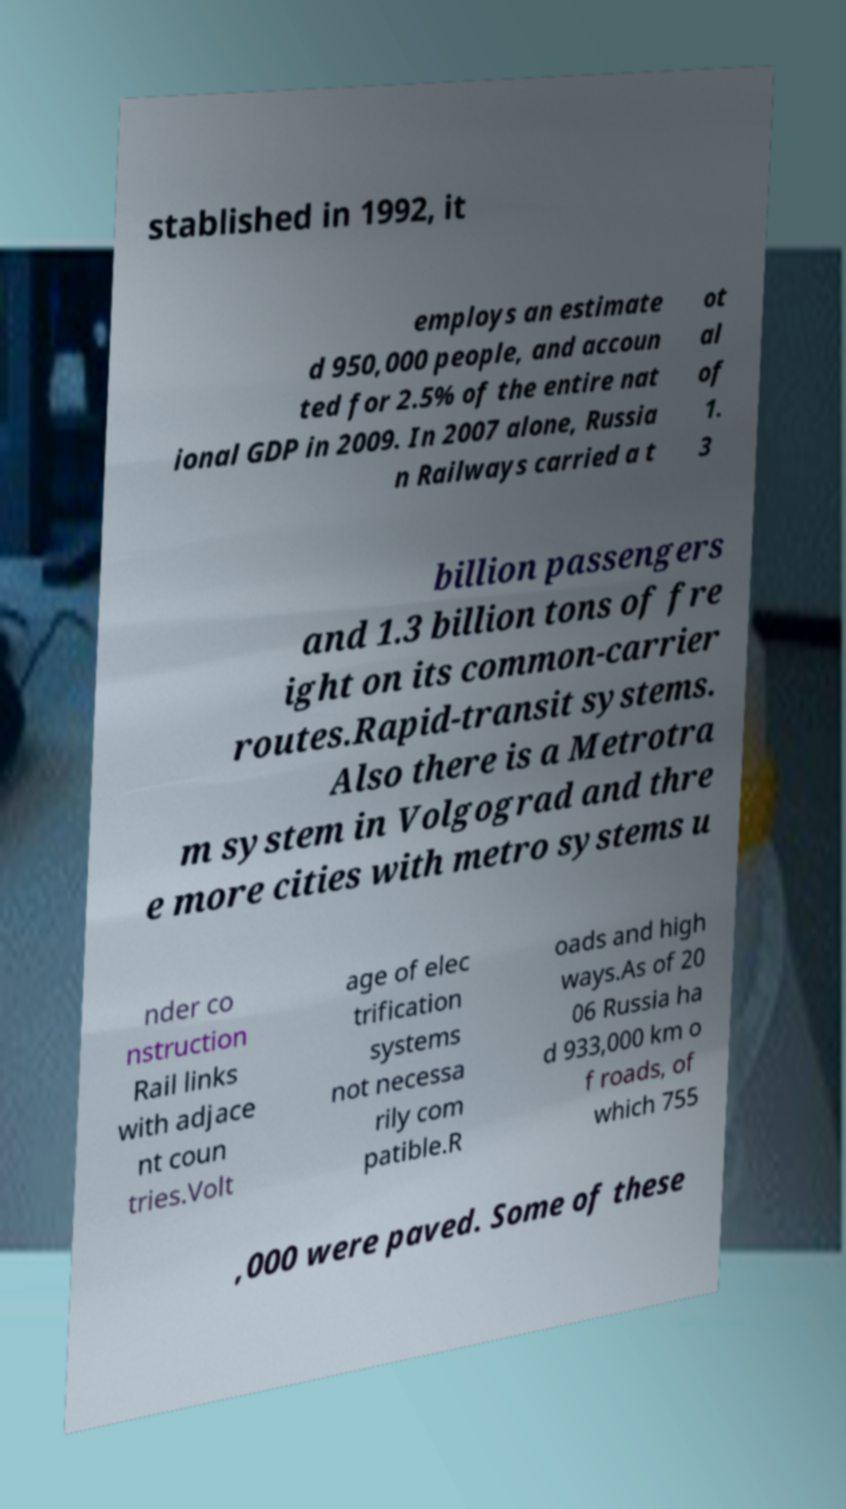For documentation purposes, I need the text within this image transcribed. Could you provide that? stablished in 1992, it employs an estimate d 950,000 people, and accoun ted for 2.5% of the entire nat ional GDP in 2009. In 2007 alone, Russia n Railways carried a t ot al of 1. 3 billion passengers and 1.3 billion tons of fre ight on its common-carrier routes.Rapid-transit systems. Also there is a Metrotra m system in Volgograd and thre e more cities with metro systems u nder co nstruction Rail links with adjace nt coun tries.Volt age of elec trification systems not necessa rily com patible.R oads and high ways.As of 20 06 Russia ha d 933,000 km o f roads, of which 755 ,000 were paved. Some of these 